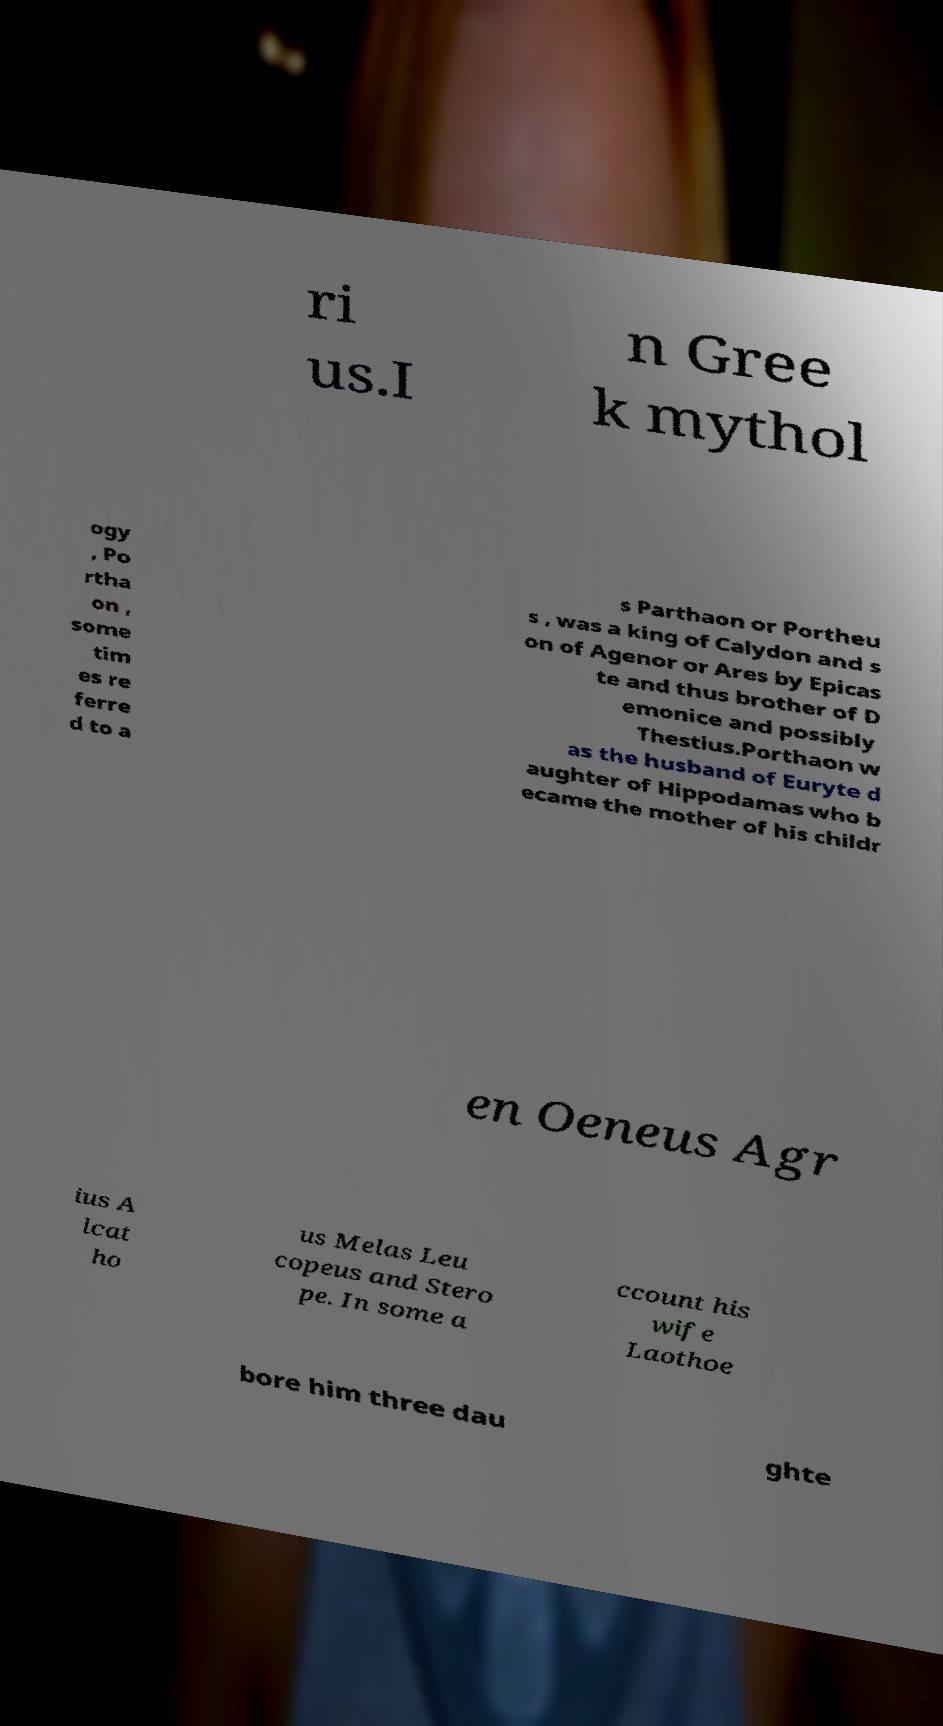For documentation purposes, I need the text within this image transcribed. Could you provide that? ri us.I n Gree k mythol ogy , Po rtha on , some tim es re ferre d to a s Parthaon or Portheu s , was a king of Calydon and s on of Agenor or Ares by Epicas te and thus brother of D emonice and possibly Thestius.Porthaon w as the husband of Euryte d aughter of Hippodamas who b ecame the mother of his childr en Oeneus Agr ius A lcat ho us Melas Leu copeus and Stero pe. In some a ccount his wife Laothoe bore him three dau ghte 